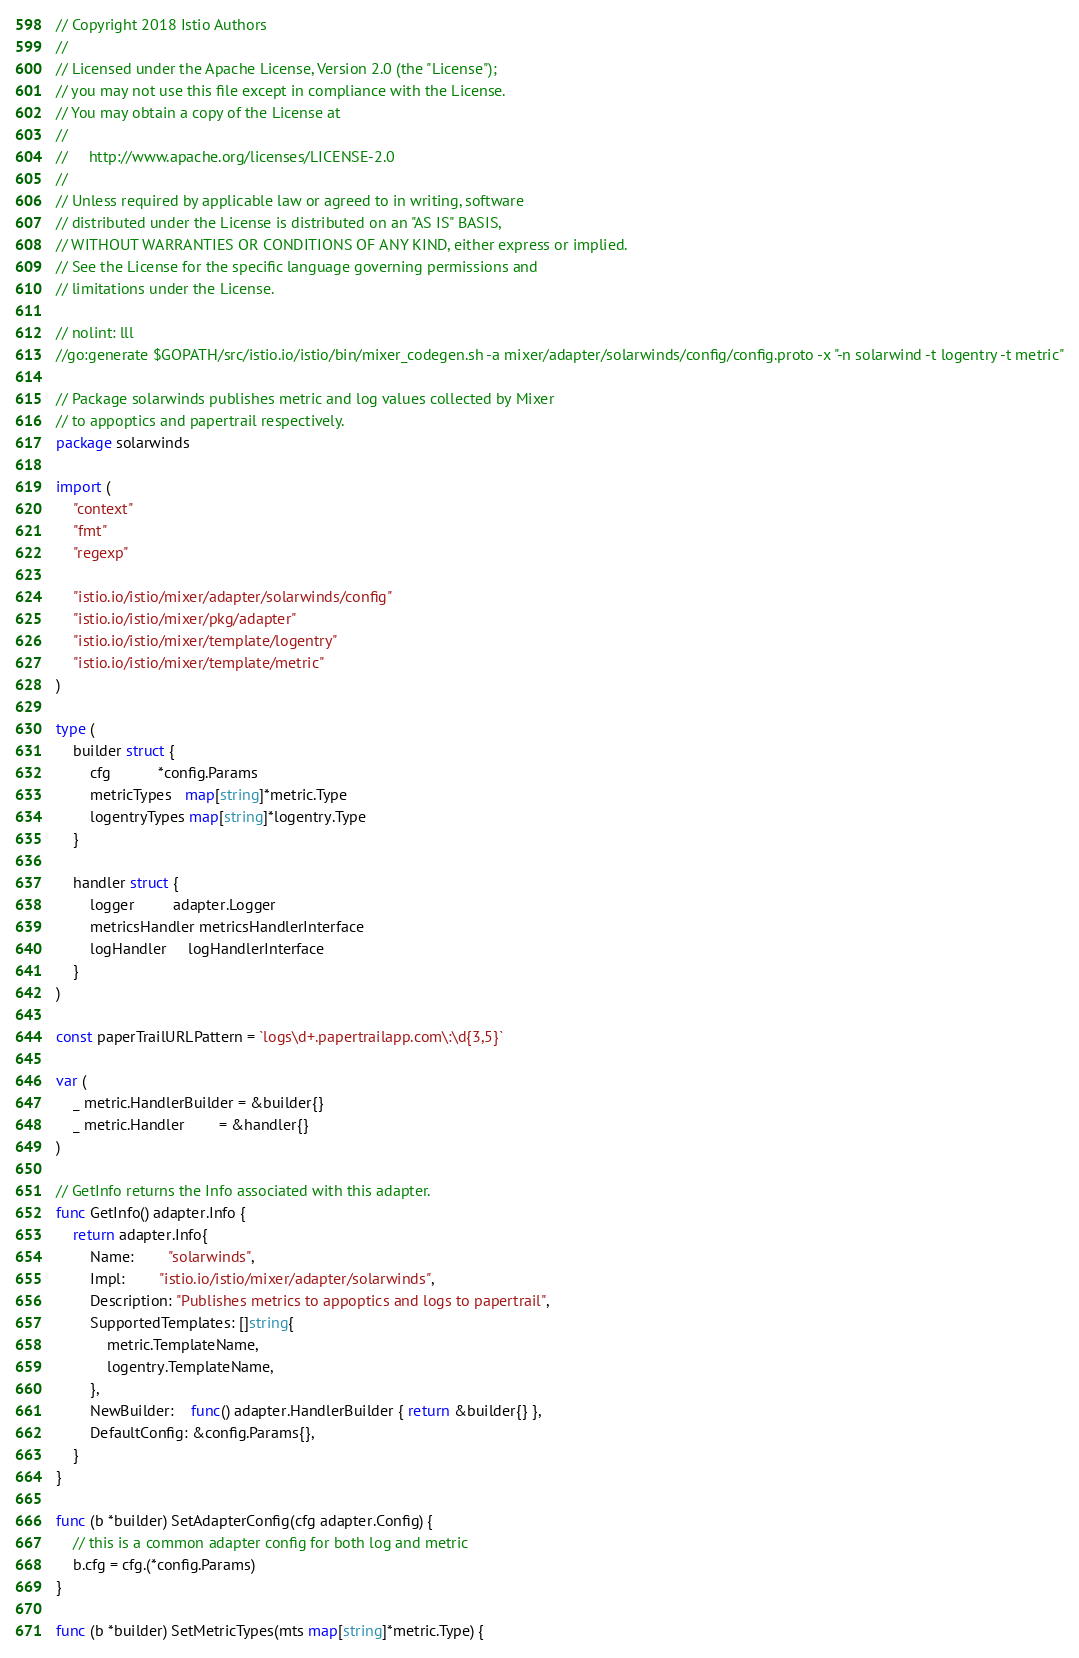Convert code to text. <code><loc_0><loc_0><loc_500><loc_500><_Go_>// Copyright 2018 Istio Authors
//
// Licensed under the Apache License, Version 2.0 (the "License");
// you may not use this file except in compliance with the License.
// You may obtain a copy of the License at
//
//     http://www.apache.org/licenses/LICENSE-2.0
//
// Unless required by applicable law or agreed to in writing, software
// distributed under the License is distributed on an "AS IS" BASIS,
// WITHOUT WARRANTIES OR CONDITIONS OF ANY KIND, either express or implied.
// See the License for the specific language governing permissions and
// limitations under the License.

// nolint: lll
//go:generate $GOPATH/src/istio.io/istio/bin/mixer_codegen.sh -a mixer/adapter/solarwinds/config/config.proto -x "-n solarwind -t logentry -t metric"

// Package solarwinds publishes metric and log values collected by Mixer
// to appoptics and papertrail respectively.
package solarwinds

import (
	"context"
	"fmt"
	"regexp"

	"istio.io/istio/mixer/adapter/solarwinds/config"
	"istio.io/istio/mixer/pkg/adapter"
	"istio.io/istio/mixer/template/logentry"
	"istio.io/istio/mixer/template/metric"
)

type (
	builder struct {
		cfg           *config.Params
		metricTypes   map[string]*metric.Type
		logentryTypes map[string]*logentry.Type
	}

	handler struct {
		logger         adapter.Logger
		metricsHandler metricsHandlerInterface
		logHandler     logHandlerInterface
	}
)

const paperTrailURLPattern = `logs\d+.papertrailapp.com\:\d{3,5}`

var (
	_ metric.HandlerBuilder = &builder{}
	_ metric.Handler        = &handler{}
)

// GetInfo returns the Info associated with this adapter.
func GetInfo() adapter.Info {
	return adapter.Info{
		Name:        "solarwinds",
		Impl:        "istio.io/istio/mixer/adapter/solarwinds",
		Description: "Publishes metrics to appoptics and logs to papertrail",
		SupportedTemplates: []string{
			metric.TemplateName,
			logentry.TemplateName,
		},
		NewBuilder:    func() adapter.HandlerBuilder { return &builder{} },
		DefaultConfig: &config.Params{},
	}
}

func (b *builder) SetAdapterConfig(cfg adapter.Config) {
	// this is a common adapter config for both log and metric
	b.cfg = cfg.(*config.Params)
}

func (b *builder) SetMetricTypes(mts map[string]*metric.Type) {</code> 